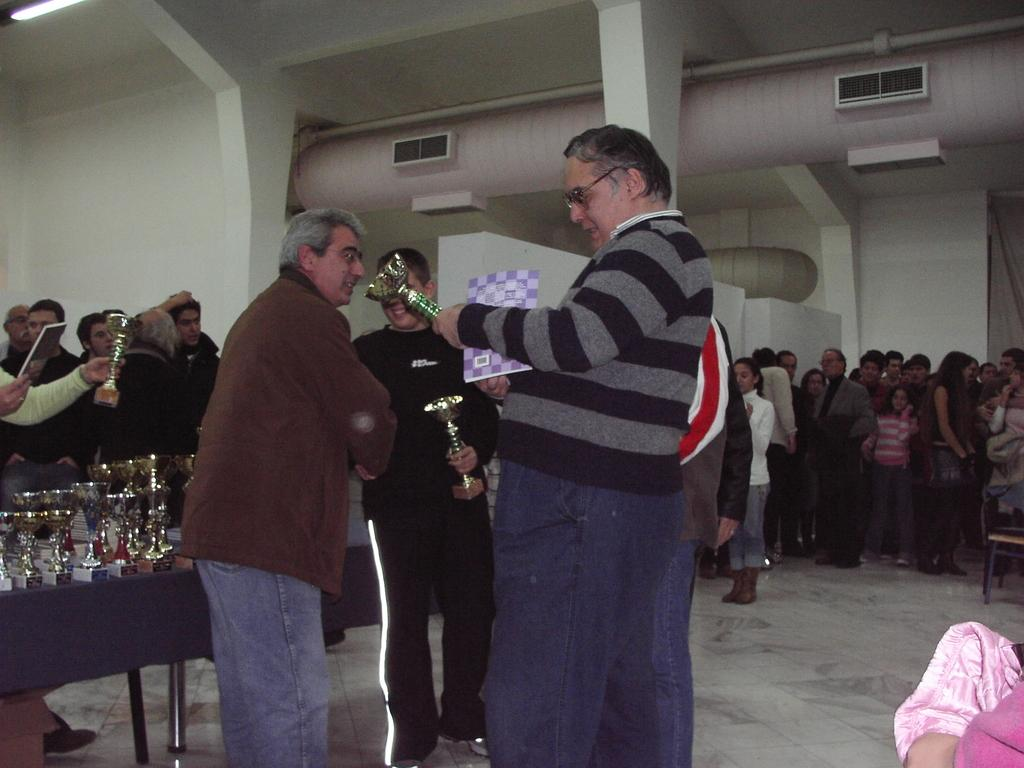What are the people in the image doing? The people in the image are standing in a queue. What is happening to the people in the queue? The people are receiving awards from a person. Where are the awards located in the image? The awards are placed on a desk in the background of the image. How does the dock increase the efficiency of the awards ceremony in the image? There is no dock present in the image, and therefore it cannot increase the efficiency of the awards ceremony. 